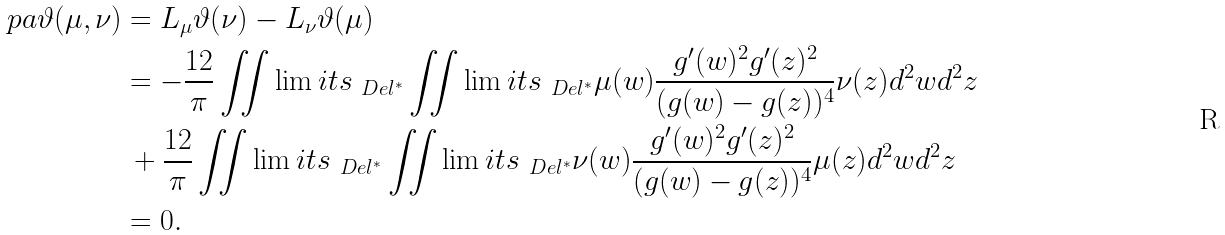Convert formula to latex. <formula><loc_0><loc_0><loc_500><loc_500>\ p a \vartheta ( \mu , \nu ) & = L _ { \mu } \vartheta ( \nu ) - L _ { \nu } \vartheta ( \mu ) \\ & = - \frac { 1 2 } { \pi } \iint \lim i t s _ { \ D e l ^ { * } } \iint \lim i t s _ { \ D e l ^ { * } } \mu ( w ) \frac { g ^ { \prime } ( w ) ^ { 2 } g ^ { \prime } ( z ) ^ { 2 } } { ( g ( w ) - g ( z ) ) ^ { 4 } } \nu ( z ) d ^ { 2 } w d ^ { 2 } z \\ & \, + \frac { 1 2 } { \pi } \iint \lim i t s _ { \ D e l ^ { * } } \iint \lim i t s _ { \ D e l ^ { * } } \nu ( w ) \frac { g ^ { \prime } ( w ) ^ { 2 } g ^ { \prime } ( z ) ^ { 2 } } { ( g ( w ) - g ( z ) ) ^ { 4 } } \mu ( z ) d ^ { 2 } w d ^ { 2 } z \\ & = 0 .</formula> 